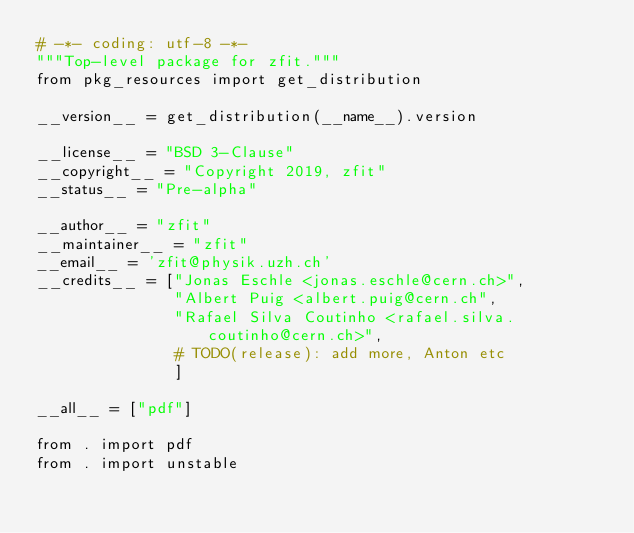<code> <loc_0><loc_0><loc_500><loc_500><_Python_># -*- coding: utf-8 -*-
"""Top-level package for zfit."""
from pkg_resources import get_distribution

__version__ = get_distribution(__name__).version

__license__ = "BSD 3-Clause"
__copyright__ = "Copyright 2019, zfit"
__status__ = "Pre-alpha"

__author__ = "zfit"
__maintainer__ = "zfit"
__email__ = 'zfit@physik.uzh.ch'
__credits__ = ["Jonas Eschle <jonas.eschle@cern.ch>",
               "Albert Puig <albert.puig@cern.ch",
               "Rafael Silva Coutinho <rafael.silva.coutinho@cern.ch>",
               # TODO(release): add more, Anton etc
               ]

__all__ = ["pdf"]

from . import pdf
from . import unstable</code> 